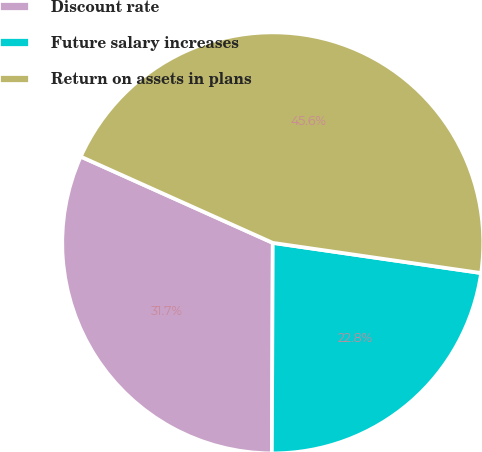<chart> <loc_0><loc_0><loc_500><loc_500><pie_chart><fcel>Discount rate<fcel>Future salary increases<fcel>Return on assets in plans<nl><fcel>31.65%<fcel>22.78%<fcel>45.57%<nl></chart> 